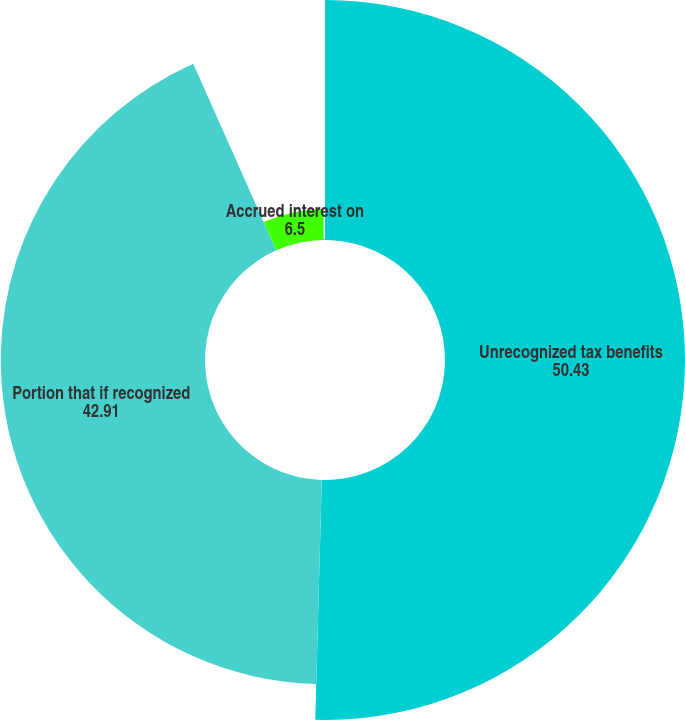Convert chart. <chart><loc_0><loc_0><loc_500><loc_500><pie_chart><fcel>Unrecognized tax benefits<fcel>Portion that if recognized<fcel>Accrued interest on<fcel>Accrued penalties on<nl><fcel>50.43%<fcel>42.91%<fcel>6.5%<fcel>0.16%<nl></chart> 